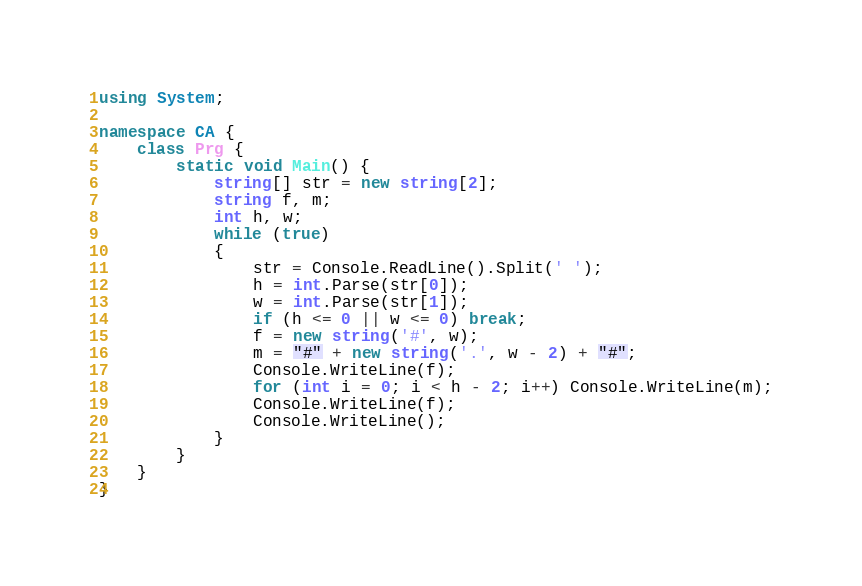<code> <loc_0><loc_0><loc_500><loc_500><_C#_>using System;

namespace CA {
	class Prg {
		static void Main() {
			string[] str = new string[2];
			string f, m;
			int h, w;
			while (true)
            {
                str = Console.ReadLine().Split(' ');
                h = int.Parse(str[0]);
                w = int.Parse(str[1]);
                if (h <= 0 || w <= 0) break;
                f = new string('#', w);
				m = "#" + new string('.', w - 2) + "#";
                Console.WriteLine(f);
                for (int i = 0; i < h - 2; i++) Console.WriteLine(m);
                Console.WriteLine(f);
                Console.WriteLine();
            }
        }
	}
}</code> 